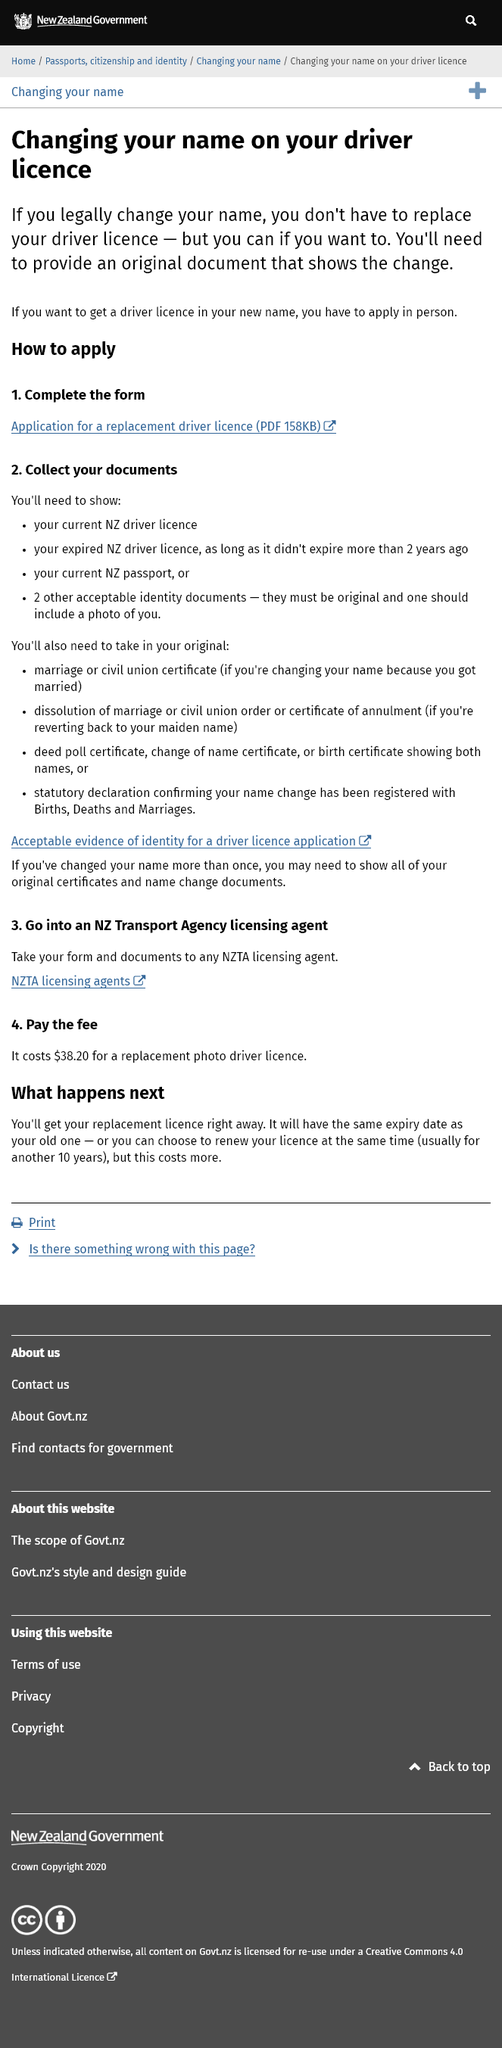Draw attention to some important aspects in this diagram. The discussion revolves around a significant identity document, namely the driver's license. The discussion is about changing the aspect of the driver's license, specifically the name. The size of the PDF file in kilobytes is 158. 